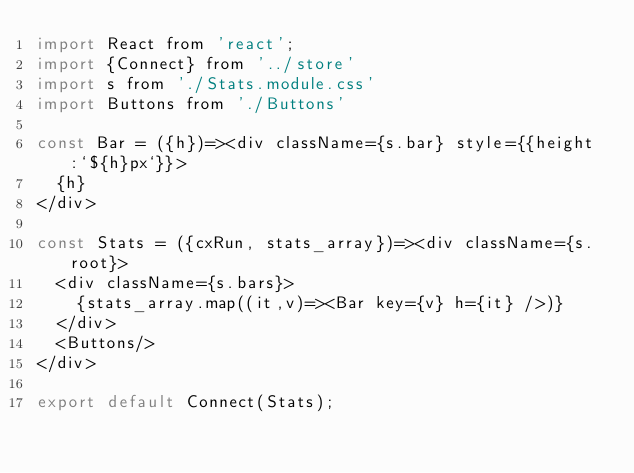<code> <loc_0><loc_0><loc_500><loc_500><_JavaScript_>import React from 'react';
import {Connect} from '../store'
import s from './Stats.module.css'
import Buttons from './Buttons'

const Bar = ({h})=><div className={s.bar} style={{height:`${h}px`}}>
  {h}
</div>

const Stats = ({cxRun, stats_array})=><div className={s.root}>
  <div className={s.bars}>
    {stats_array.map((it,v)=><Bar key={v} h={it} />)}
  </div>
  <Buttons/>
</div>

export default Connect(Stats);

</code> 